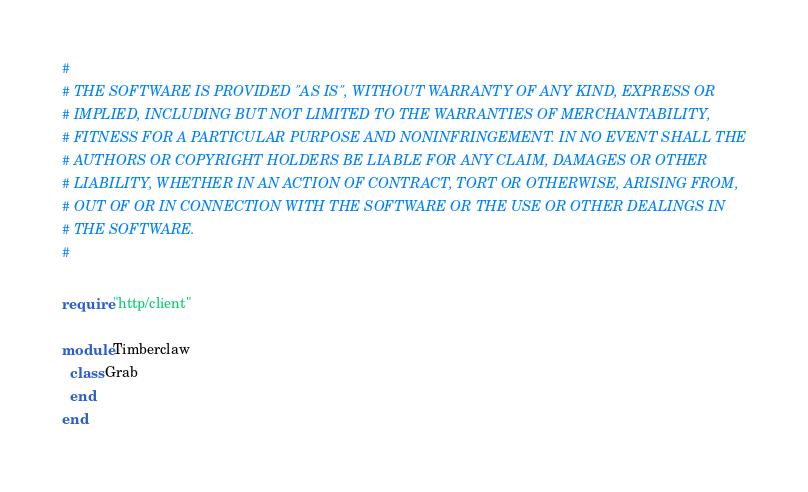<code> <loc_0><loc_0><loc_500><loc_500><_Crystal_>#
# THE SOFTWARE IS PROVIDED "AS IS", WITHOUT WARRANTY OF ANY KIND, EXPRESS OR
# IMPLIED, INCLUDING BUT NOT LIMITED TO THE WARRANTIES OF MERCHANTABILITY,
# FITNESS FOR A PARTICULAR PURPOSE AND NONINFRINGEMENT. IN NO EVENT SHALL THE
# AUTHORS OR COPYRIGHT HOLDERS BE LIABLE FOR ANY CLAIM, DAMAGES OR OTHER
# LIABILITY, WHETHER IN AN ACTION OF CONTRACT, TORT OR OTHERWISE, ARISING FROM,
# OUT OF OR IN CONNECTION WITH THE SOFTWARE OR THE USE OR OTHER DEALINGS IN
# THE SOFTWARE.
#

require "http/client"

module Timberclaw
  class Grab
  end
end
</code> 